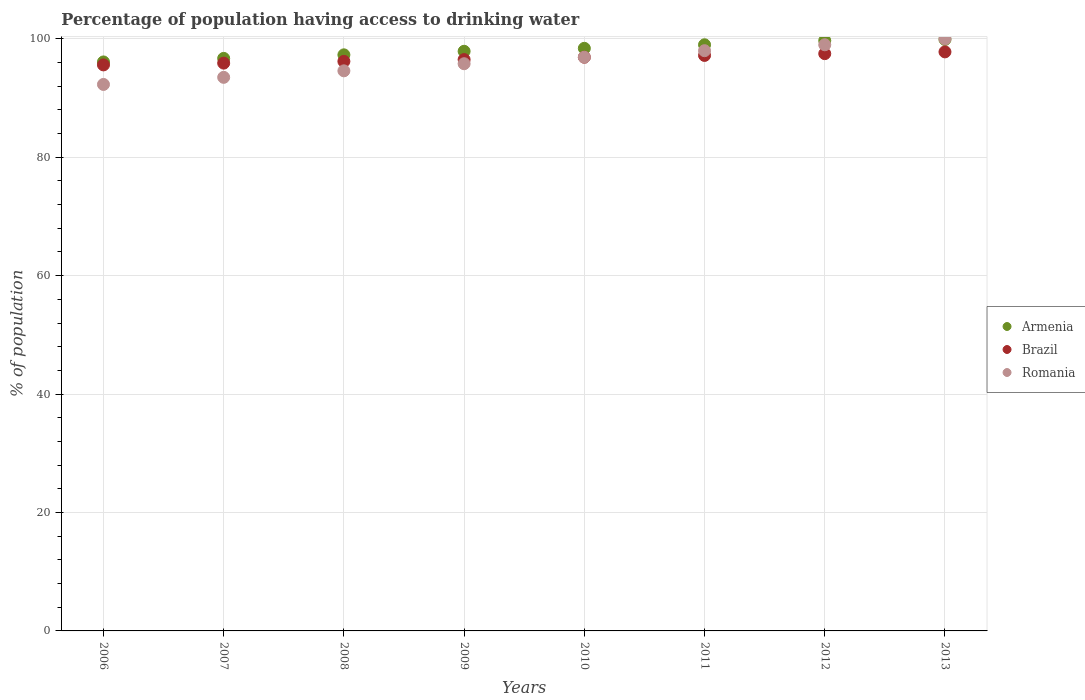How many different coloured dotlines are there?
Offer a very short reply. 3. Is the number of dotlines equal to the number of legend labels?
Keep it short and to the point. Yes. What is the percentage of population having access to drinking water in Brazil in 2009?
Your response must be concise. 96.5. Across all years, what is the maximum percentage of population having access to drinking water in Brazil?
Your answer should be very brief. 97.8. Across all years, what is the minimum percentage of population having access to drinking water in Brazil?
Your answer should be compact. 95.6. What is the total percentage of population having access to drinking water in Brazil in the graph?
Offer a very short reply. 773.6. What is the difference between the percentage of population having access to drinking water in Brazil in 2007 and that in 2008?
Ensure brevity in your answer.  -0.3. What is the difference between the percentage of population having access to drinking water in Brazil in 2006 and the percentage of population having access to drinking water in Armenia in 2008?
Offer a terse response. -1.7. What is the average percentage of population having access to drinking water in Romania per year?
Your response must be concise. 96.26. In the year 2007, what is the difference between the percentage of population having access to drinking water in Romania and percentage of population having access to drinking water in Armenia?
Provide a short and direct response. -3.2. In how many years, is the percentage of population having access to drinking water in Brazil greater than 36 %?
Offer a terse response. 8. What is the ratio of the percentage of population having access to drinking water in Brazil in 2011 to that in 2013?
Give a very brief answer. 0.99. Is the percentage of population having access to drinking water in Armenia in 2007 less than that in 2013?
Give a very brief answer. Yes. What is the difference between the highest and the second highest percentage of population having access to drinking water in Brazil?
Your response must be concise. 0.3. What is the difference between the highest and the lowest percentage of population having access to drinking water in Romania?
Provide a succinct answer. 7.7. In how many years, is the percentage of population having access to drinking water in Armenia greater than the average percentage of population having access to drinking water in Armenia taken over all years?
Provide a short and direct response. 4. Does the percentage of population having access to drinking water in Brazil monotonically increase over the years?
Provide a short and direct response. Yes. How many dotlines are there?
Your answer should be very brief. 3. How many years are there in the graph?
Offer a terse response. 8. What is the difference between two consecutive major ticks on the Y-axis?
Give a very brief answer. 20. Where does the legend appear in the graph?
Offer a terse response. Center right. How many legend labels are there?
Ensure brevity in your answer.  3. What is the title of the graph?
Offer a terse response. Percentage of population having access to drinking water. What is the label or title of the Y-axis?
Offer a terse response. % of population. What is the % of population in Armenia in 2006?
Offer a terse response. 96.1. What is the % of population in Brazil in 2006?
Offer a very short reply. 95.6. What is the % of population in Romania in 2006?
Offer a terse response. 92.3. What is the % of population of Armenia in 2007?
Offer a very short reply. 96.7. What is the % of population of Brazil in 2007?
Keep it short and to the point. 95.9. What is the % of population of Romania in 2007?
Your response must be concise. 93.5. What is the % of population in Armenia in 2008?
Your answer should be very brief. 97.3. What is the % of population of Brazil in 2008?
Provide a short and direct response. 96.2. What is the % of population in Romania in 2008?
Ensure brevity in your answer.  94.6. What is the % of population in Armenia in 2009?
Your answer should be very brief. 97.9. What is the % of population in Brazil in 2009?
Keep it short and to the point. 96.5. What is the % of population of Romania in 2009?
Your answer should be compact. 95.8. What is the % of population in Armenia in 2010?
Offer a very short reply. 98.4. What is the % of population in Brazil in 2010?
Your answer should be very brief. 96.9. What is the % of population of Romania in 2010?
Offer a terse response. 96.9. What is the % of population of Armenia in 2011?
Your response must be concise. 99. What is the % of population of Brazil in 2011?
Offer a very short reply. 97.2. What is the % of population in Romania in 2011?
Offer a very short reply. 98. What is the % of population of Armenia in 2012?
Provide a succinct answer. 99.7. What is the % of population in Brazil in 2012?
Provide a succinct answer. 97.5. What is the % of population of Armenia in 2013?
Keep it short and to the point. 99.9. What is the % of population of Brazil in 2013?
Keep it short and to the point. 97.8. Across all years, what is the maximum % of population in Armenia?
Give a very brief answer. 99.9. Across all years, what is the maximum % of population in Brazil?
Ensure brevity in your answer.  97.8. Across all years, what is the maximum % of population in Romania?
Provide a short and direct response. 100. Across all years, what is the minimum % of population of Armenia?
Your answer should be compact. 96.1. Across all years, what is the minimum % of population in Brazil?
Make the answer very short. 95.6. Across all years, what is the minimum % of population in Romania?
Your answer should be compact. 92.3. What is the total % of population in Armenia in the graph?
Your answer should be compact. 785. What is the total % of population of Brazil in the graph?
Provide a succinct answer. 773.6. What is the total % of population in Romania in the graph?
Make the answer very short. 770.1. What is the difference between the % of population in Brazil in 2006 and that in 2007?
Your answer should be very brief. -0.3. What is the difference between the % of population in Romania in 2006 and that in 2007?
Offer a very short reply. -1.2. What is the difference between the % of population of Brazil in 2006 and that in 2009?
Keep it short and to the point. -0.9. What is the difference between the % of population in Romania in 2006 and that in 2009?
Offer a very short reply. -3.5. What is the difference between the % of population in Brazil in 2006 and that in 2011?
Offer a terse response. -1.6. What is the difference between the % of population of Romania in 2006 and that in 2011?
Give a very brief answer. -5.7. What is the difference between the % of population in Armenia in 2006 and that in 2012?
Ensure brevity in your answer.  -3.6. What is the difference between the % of population of Romania in 2006 and that in 2012?
Keep it short and to the point. -6.7. What is the difference between the % of population in Romania in 2006 and that in 2013?
Make the answer very short. -7.7. What is the difference between the % of population of Romania in 2007 and that in 2008?
Keep it short and to the point. -1.1. What is the difference between the % of population in Armenia in 2007 and that in 2009?
Your response must be concise. -1.2. What is the difference between the % of population in Romania in 2007 and that in 2009?
Your answer should be compact. -2.3. What is the difference between the % of population of Romania in 2007 and that in 2010?
Your answer should be very brief. -3.4. What is the difference between the % of population of Armenia in 2007 and that in 2011?
Your response must be concise. -2.3. What is the difference between the % of population of Brazil in 2007 and that in 2011?
Give a very brief answer. -1.3. What is the difference between the % of population in Romania in 2007 and that in 2011?
Make the answer very short. -4.5. What is the difference between the % of population in Armenia in 2007 and that in 2012?
Ensure brevity in your answer.  -3. What is the difference between the % of population of Brazil in 2007 and that in 2012?
Provide a short and direct response. -1.6. What is the difference between the % of population of Romania in 2007 and that in 2012?
Your answer should be very brief. -5.5. What is the difference between the % of population in Armenia in 2008 and that in 2010?
Ensure brevity in your answer.  -1.1. What is the difference between the % of population of Brazil in 2008 and that in 2011?
Provide a short and direct response. -1. What is the difference between the % of population of Romania in 2008 and that in 2011?
Give a very brief answer. -3.4. What is the difference between the % of population of Armenia in 2008 and that in 2012?
Offer a terse response. -2.4. What is the difference between the % of population in Romania in 2008 and that in 2012?
Provide a succinct answer. -4.4. What is the difference between the % of population of Brazil in 2008 and that in 2013?
Offer a terse response. -1.6. What is the difference between the % of population in Armenia in 2009 and that in 2011?
Keep it short and to the point. -1.1. What is the difference between the % of population of Brazil in 2009 and that in 2011?
Your answer should be compact. -0.7. What is the difference between the % of population of Romania in 2009 and that in 2011?
Ensure brevity in your answer.  -2.2. What is the difference between the % of population of Armenia in 2009 and that in 2012?
Offer a terse response. -1.8. What is the difference between the % of population of Armenia in 2009 and that in 2013?
Make the answer very short. -2. What is the difference between the % of population in Romania in 2009 and that in 2013?
Offer a very short reply. -4.2. What is the difference between the % of population of Armenia in 2010 and that in 2011?
Ensure brevity in your answer.  -0.6. What is the difference between the % of population of Brazil in 2010 and that in 2011?
Offer a very short reply. -0.3. What is the difference between the % of population in Romania in 2010 and that in 2011?
Give a very brief answer. -1.1. What is the difference between the % of population of Brazil in 2010 and that in 2012?
Your answer should be very brief. -0.6. What is the difference between the % of population of Romania in 2010 and that in 2012?
Keep it short and to the point. -2.1. What is the difference between the % of population in Brazil in 2010 and that in 2013?
Ensure brevity in your answer.  -0.9. What is the difference between the % of population of Romania in 2011 and that in 2012?
Provide a short and direct response. -1. What is the difference between the % of population in Brazil in 2011 and that in 2013?
Offer a terse response. -0.6. What is the difference between the % of population of Romania in 2012 and that in 2013?
Give a very brief answer. -1. What is the difference between the % of population in Armenia in 2006 and the % of population in Brazil in 2007?
Provide a short and direct response. 0.2. What is the difference between the % of population of Armenia in 2006 and the % of population of Romania in 2007?
Provide a short and direct response. 2.6. What is the difference between the % of population in Brazil in 2006 and the % of population in Romania in 2008?
Provide a succinct answer. 1. What is the difference between the % of population of Armenia in 2006 and the % of population of Brazil in 2009?
Provide a short and direct response. -0.4. What is the difference between the % of population of Armenia in 2006 and the % of population of Romania in 2009?
Your answer should be very brief. 0.3. What is the difference between the % of population of Brazil in 2006 and the % of population of Romania in 2009?
Your answer should be very brief. -0.2. What is the difference between the % of population of Armenia in 2006 and the % of population of Brazil in 2010?
Give a very brief answer. -0.8. What is the difference between the % of population in Brazil in 2006 and the % of population in Romania in 2010?
Give a very brief answer. -1.3. What is the difference between the % of population of Brazil in 2006 and the % of population of Romania in 2011?
Provide a short and direct response. -2.4. What is the difference between the % of population of Armenia in 2006 and the % of population of Romania in 2012?
Provide a short and direct response. -2.9. What is the difference between the % of population in Armenia in 2006 and the % of population in Brazil in 2013?
Make the answer very short. -1.7. What is the difference between the % of population in Armenia in 2006 and the % of population in Romania in 2013?
Your answer should be compact. -3.9. What is the difference between the % of population of Brazil in 2006 and the % of population of Romania in 2013?
Keep it short and to the point. -4.4. What is the difference between the % of population of Armenia in 2007 and the % of population of Brazil in 2009?
Make the answer very short. 0.2. What is the difference between the % of population in Armenia in 2007 and the % of population in Romania in 2009?
Provide a short and direct response. 0.9. What is the difference between the % of population of Armenia in 2007 and the % of population of Brazil in 2011?
Your response must be concise. -0.5. What is the difference between the % of population in Armenia in 2007 and the % of population in Brazil in 2012?
Your answer should be compact. -0.8. What is the difference between the % of population in Armenia in 2007 and the % of population in Romania in 2013?
Your response must be concise. -3.3. What is the difference between the % of population in Armenia in 2008 and the % of population in Romania in 2009?
Provide a short and direct response. 1.5. What is the difference between the % of population in Brazil in 2008 and the % of population in Romania in 2010?
Provide a succinct answer. -0.7. What is the difference between the % of population of Brazil in 2008 and the % of population of Romania in 2011?
Ensure brevity in your answer.  -1.8. What is the difference between the % of population in Armenia in 2008 and the % of population in Brazil in 2012?
Offer a terse response. -0.2. What is the difference between the % of population in Armenia in 2008 and the % of population in Romania in 2012?
Provide a succinct answer. -1.7. What is the difference between the % of population of Brazil in 2008 and the % of population of Romania in 2012?
Keep it short and to the point. -2.8. What is the difference between the % of population of Armenia in 2009 and the % of population of Brazil in 2010?
Keep it short and to the point. 1. What is the difference between the % of population of Brazil in 2009 and the % of population of Romania in 2010?
Your answer should be compact. -0.4. What is the difference between the % of population in Brazil in 2009 and the % of population in Romania in 2011?
Your response must be concise. -1.5. What is the difference between the % of population in Brazil in 2009 and the % of population in Romania in 2012?
Provide a succinct answer. -2.5. What is the difference between the % of population in Brazil in 2009 and the % of population in Romania in 2013?
Your response must be concise. -3.5. What is the difference between the % of population of Armenia in 2010 and the % of population of Romania in 2011?
Keep it short and to the point. 0.4. What is the difference between the % of population in Brazil in 2010 and the % of population in Romania in 2011?
Your answer should be very brief. -1.1. What is the difference between the % of population in Armenia in 2010 and the % of population in Brazil in 2012?
Your answer should be compact. 0.9. What is the difference between the % of population in Armenia in 2010 and the % of population in Romania in 2012?
Offer a very short reply. -0.6. What is the difference between the % of population in Brazil in 2010 and the % of population in Romania in 2012?
Keep it short and to the point. -2.1. What is the difference between the % of population in Armenia in 2010 and the % of population in Romania in 2013?
Provide a succinct answer. -1.6. What is the difference between the % of population in Brazil in 2010 and the % of population in Romania in 2013?
Offer a terse response. -3.1. What is the difference between the % of population in Armenia in 2011 and the % of population in Romania in 2012?
Keep it short and to the point. 0. What is the difference between the % of population of Brazil in 2011 and the % of population of Romania in 2012?
Offer a very short reply. -1.8. What is the difference between the % of population in Armenia in 2011 and the % of population in Romania in 2013?
Your response must be concise. -1. What is the difference between the % of population of Brazil in 2011 and the % of population of Romania in 2013?
Keep it short and to the point. -2.8. What is the difference between the % of population of Brazil in 2012 and the % of population of Romania in 2013?
Give a very brief answer. -2.5. What is the average % of population of Armenia per year?
Keep it short and to the point. 98.12. What is the average % of population of Brazil per year?
Keep it short and to the point. 96.7. What is the average % of population in Romania per year?
Ensure brevity in your answer.  96.26. In the year 2006, what is the difference between the % of population of Armenia and % of population of Romania?
Provide a succinct answer. 3.8. In the year 2006, what is the difference between the % of population in Brazil and % of population in Romania?
Your answer should be compact. 3.3. In the year 2007, what is the difference between the % of population in Brazil and % of population in Romania?
Offer a very short reply. 2.4. In the year 2008, what is the difference between the % of population of Armenia and % of population of Brazil?
Your answer should be compact. 1.1. In the year 2009, what is the difference between the % of population of Armenia and % of population of Romania?
Provide a short and direct response. 2.1. In the year 2010, what is the difference between the % of population of Armenia and % of population of Brazil?
Provide a succinct answer. 1.5. In the year 2010, what is the difference between the % of population in Armenia and % of population in Romania?
Make the answer very short. 1.5. In the year 2010, what is the difference between the % of population of Brazil and % of population of Romania?
Give a very brief answer. 0. In the year 2011, what is the difference between the % of population in Armenia and % of population in Brazil?
Provide a succinct answer. 1.8. In the year 2011, what is the difference between the % of population of Brazil and % of population of Romania?
Keep it short and to the point. -0.8. In the year 2012, what is the difference between the % of population of Armenia and % of population of Brazil?
Your answer should be very brief. 2.2. In the year 2012, what is the difference between the % of population of Armenia and % of population of Romania?
Keep it short and to the point. 0.7. In the year 2013, what is the difference between the % of population in Brazil and % of population in Romania?
Your answer should be very brief. -2.2. What is the ratio of the % of population in Brazil in 2006 to that in 2007?
Make the answer very short. 1. What is the ratio of the % of population of Romania in 2006 to that in 2007?
Provide a short and direct response. 0.99. What is the ratio of the % of population of Armenia in 2006 to that in 2008?
Provide a succinct answer. 0.99. What is the ratio of the % of population in Brazil in 2006 to that in 2008?
Offer a very short reply. 0.99. What is the ratio of the % of population of Romania in 2006 to that in 2008?
Keep it short and to the point. 0.98. What is the ratio of the % of population of Armenia in 2006 to that in 2009?
Offer a very short reply. 0.98. What is the ratio of the % of population in Romania in 2006 to that in 2009?
Provide a succinct answer. 0.96. What is the ratio of the % of population of Armenia in 2006 to that in 2010?
Give a very brief answer. 0.98. What is the ratio of the % of population of Brazil in 2006 to that in 2010?
Your response must be concise. 0.99. What is the ratio of the % of population in Romania in 2006 to that in 2010?
Provide a short and direct response. 0.95. What is the ratio of the % of population of Armenia in 2006 to that in 2011?
Your response must be concise. 0.97. What is the ratio of the % of population in Brazil in 2006 to that in 2011?
Offer a terse response. 0.98. What is the ratio of the % of population in Romania in 2006 to that in 2011?
Provide a succinct answer. 0.94. What is the ratio of the % of population of Armenia in 2006 to that in 2012?
Ensure brevity in your answer.  0.96. What is the ratio of the % of population in Brazil in 2006 to that in 2012?
Your answer should be compact. 0.98. What is the ratio of the % of population of Romania in 2006 to that in 2012?
Ensure brevity in your answer.  0.93. What is the ratio of the % of population in Brazil in 2006 to that in 2013?
Your answer should be very brief. 0.98. What is the ratio of the % of population of Romania in 2006 to that in 2013?
Provide a succinct answer. 0.92. What is the ratio of the % of population in Romania in 2007 to that in 2008?
Your response must be concise. 0.99. What is the ratio of the % of population in Armenia in 2007 to that in 2009?
Your response must be concise. 0.99. What is the ratio of the % of population in Armenia in 2007 to that in 2010?
Offer a terse response. 0.98. What is the ratio of the % of population of Brazil in 2007 to that in 2010?
Offer a very short reply. 0.99. What is the ratio of the % of population in Romania in 2007 to that in 2010?
Offer a very short reply. 0.96. What is the ratio of the % of population of Armenia in 2007 to that in 2011?
Your response must be concise. 0.98. What is the ratio of the % of population in Brazil in 2007 to that in 2011?
Offer a terse response. 0.99. What is the ratio of the % of population of Romania in 2007 to that in 2011?
Provide a succinct answer. 0.95. What is the ratio of the % of population of Armenia in 2007 to that in 2012?
Your response must be concise. 0.97. What is the ratio of the % of population of Brazil in 2007 to that in 2012?
Provide a succinct answer. 0.98. What is the ratio of the % of population in Armenia in 2007 to that in 2013?
Provide a short and direct response. 0.97. What is the ratio of the % of population in Brazil in 2007 to that in 2013?
Provide a short and direct response. 0.98. What is the ratio of the % of population of Romania in 2007 to that in 2013?
Your answer should be very brief. 0.94. What is the ratio of the % of population of Brazil in 2008 to that in 2009?
Offer a very short reply. 1. What is the ratio of the % of population in Romania in 2008 to that in 2009?
Your answer should be very brief. 0.99. What is the ratio of the % of population of Romania in 2008 to that in 2010?
Offer a very short reply. 0.98. What is the ratio of the % of population of Armenia in 2008 to that in 2011?
Make the answer very short. 0.98. What is the ratio of the % of population in Brazil in 2008 to that in 2011?
Offer a terse response. 0.99. What is the ratio of the % of population of Romania in 2008 to that in 2011?
Give a very brief answer. 0.97. What is the ratio of the % of population of Armenia in 2008 to that in 2012?
Provide a short and direct response. 0.98. What is the ratio of the % of population of Brazil in 2008 to that in 2012?
Provide a succinct answer. 0.99. What is the ratio of the % of population in Romania in 2008 to that in 2012?
Ensure brevity in your answer.  0.96. What is the ratio of the % of population in Brazil in 2008 to that in 2013?
Ensure brevity in your answer.  0.98. What is the ratio of the % of population in Romania in 2008 to that in 2013?
Your answer should be very brief. 0.95. What is the ratio of the % of population of Brazil in 2009 to that in 2010?
Offer a terse response. 1. What is the ratio of the % of population of Romania in 2009 to that in 2010?
Your response must be concise. 0.99. What is the ratio of the % of population of Armenia in 2009 to that in 2011?
Give a very brief answer. 0.99. What is the ratio of the % of population of Romania in 2009 to that in 2011?
Your answer should be very brief. 0.98. What is the ratio of the % of population in Armenia in 2009 to that in 2012?
Make the answer very short. 0.98. What is the ratio of the % of population in Armenia in 2009 to that in 2013?
Ensure brevity in your answer.  0.98. What is the ratio of the % of population of Brazil in 2009 to that in 2013?
Ensure brevity in your answer.  0.99. What is the ratio of the % of population of Romania in 2009 to that in 2013?
Make the answer very short. 0.96. What is the ratio of the % of population of Brazil in 2010 to that in 2011?
Ensure brevity in your answer.  1. What is the ratio of the % of population of Armenia in 2010 to that in 2012?
Make the answer very short. 0.99. What is the ratio of the % of population of Brazil in 2010 to that in 2012?
Provide a succinct answer. 0.99. What is the ratio of the % of population of Romania in 2010 to that in 2012?
Give a very brief answer. 0.98. What is the ratio of the % of population in Armenia in 2010 to that in 2013?
Make the answer very short. 0.98. What is the ratio of the % of population in Brazil in 2010 to that in 2013?
Offer a terse response. 0.99. What is the ratio of the % of population of Romania in 2010 to that in 2013?
Your answer should be compact. 0.97. What is the ratio of the % of population in Brazil in 2011 to that in 2012?
Your response must be concise. 1. What is the ratio of the % of population of Armenia in 2011 to that in 2013?
Offer a very short reply. 0.99. What is the ratio of the % of population of Romania in 2011 to that in 2013?
Offer a terse response. 0.98. What is the ratio of the % of population in Armenia in 2012 to that in 2013?
Your answer should be compact. 1. What is the ratio of the % of population of Brazil in 2012 to that in 2013?
Your response must be concise. 1. What is the ratio of the % of population in Romania in 2012 to that in 2013?
Ensure brevity in your answer.  0.99. What is the difference between the highest and the second highest % of population in Armenia?
Your answer should be very brief. 0.2. What is the difference between the highest and the second highest % of population in Brazil?
Your answer should be compact. 0.3. What is the difference between the highest and the second highest % of population in Romania?
Offer a very short reply. 1. What is the difference between the highest and the lowest % of population of Romania?
Your answer should be compact. 7.7. 